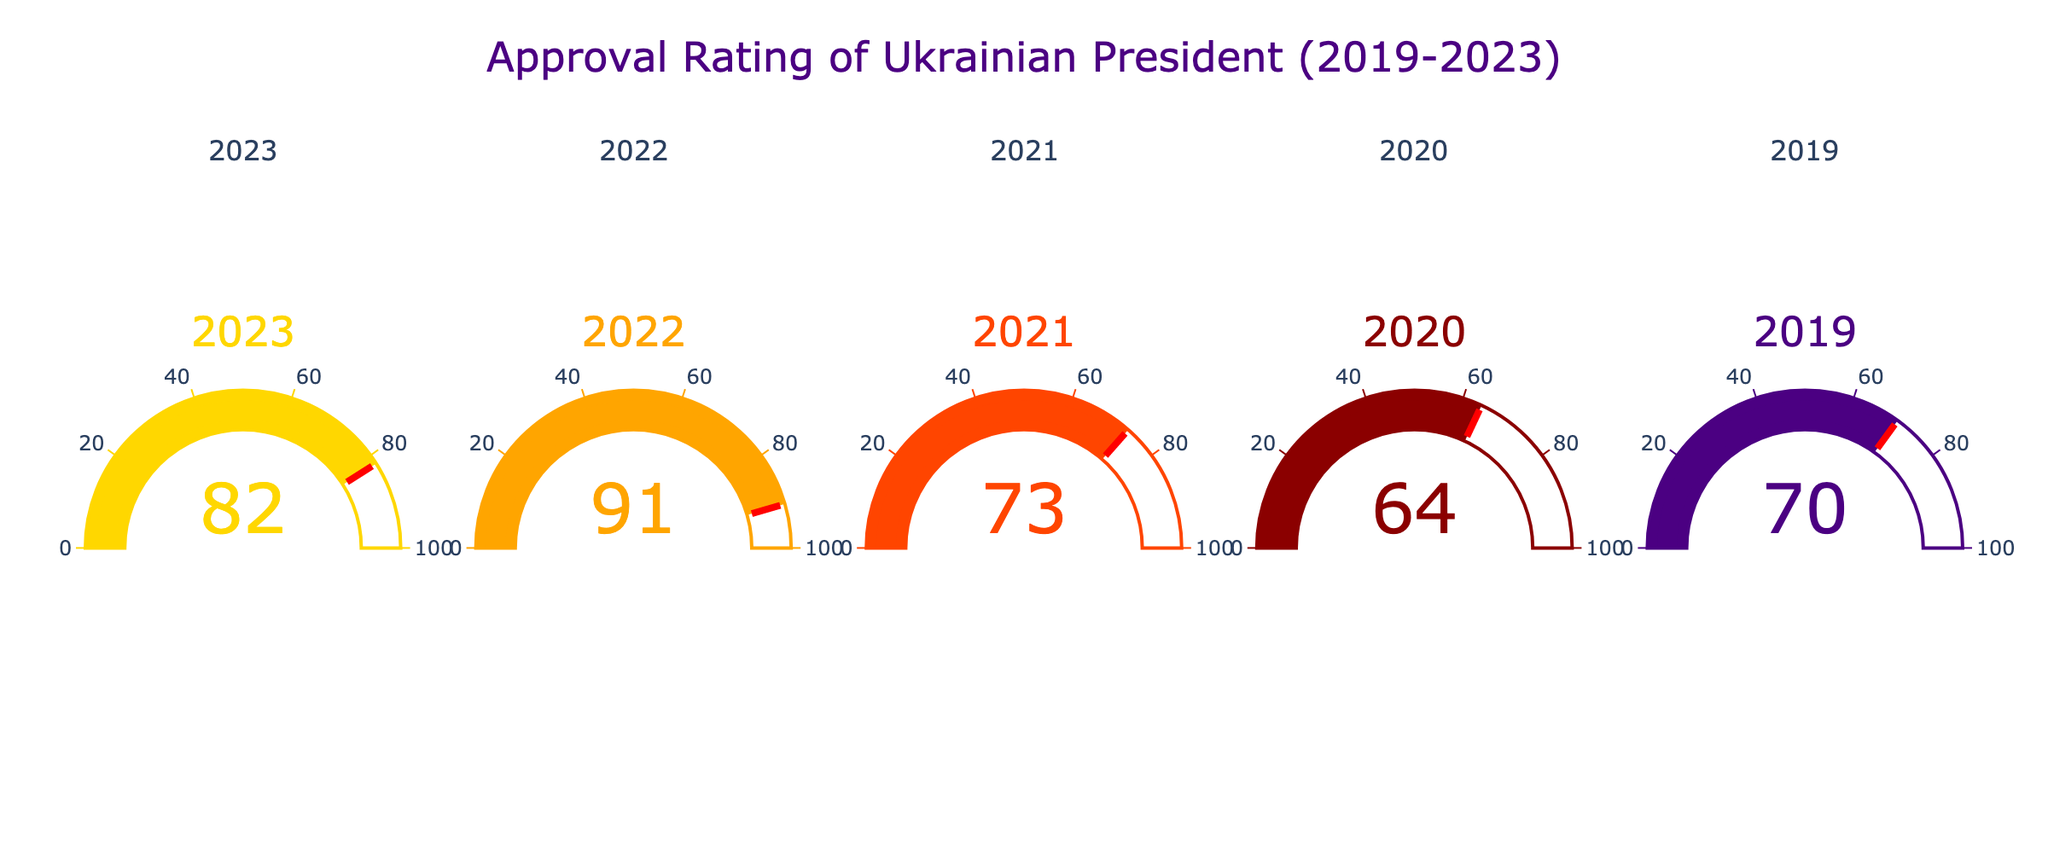How many data points are shown in the figure? The figure displays gauges for different years, each representing a data point. Counting the number of distinct years shown will give the number of data points. There are 5 gauges corresponding to the years 2019, 2020, 2021, 2022, and 2023.
Answer: 5 What's the year with the highest approval rating? By looking at the gauge chart, identify which gauge shows the highest number. The gauge for the year 2022 displays the highest approval rating of 91.
Answer: 2022 What is the total approval rating for all the years combined? Add the approval ratings for each year from 2019 to 2023: 70 + 64 + 73 + 91 + 82. The sum is 380.
Answer: 380 What is the average approval rating from 2019 to 2023? To find the average, sum all the approval ratings and divide by the number of years: (70 + 64 + 73 + 91 + 82) / 5. The average is 76.
Answer: 76 In which year did the approval rating decrease compared to the previous year? Compare the approval ratings of consecutive years. The approval rating decreased from 2022 (91) to 2023 (82) and from 2019 (70) to 2020 (64).
Answer: 2023, 2020 Which year had the lowest approval rating? By examining the gauge chart, identify the lowest number displayed. The gauge for 2020 shows the lowest approval rating of 64.
Answer: 2020 By how much did the approval rating increase from 2020 to 2021? Subtract the approval rating of 2020 from that of 2021: 73 - 64. The increase is 9.
Answer: 9 What is the median approval rating over the 5 years? Order the approval ratings: 64, 70, 73, 82, 91. The median value is the middle one of the sorted list, which is 73.
Answer: 73 Which year saw the biggest increase in approval rating compared to its previous year? Calculate the difference in approval ratings for each pair of consecutive years: from 2019 to 2020 is -6, from 2020 to 2021 is +9, from 2021 to 2022 is +18, and from 2022 to 2023 is -9. The biggest increase is from 2021 to 2022 with +18.
Answer: 2022 